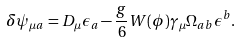Convert formula to latex. <formula><loc_0><loc_0><loc_500><loc_500>\delta \psi _ { \mu a } = D _ { \mu } \epsilon _ { a } - \frac { g } { 6 } W ( \phi ) \gamma _ { \mu } \Omega _ { a b } \epsilon ^ { b } .</formula> 